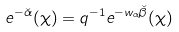Convert formula to latex. <formula><loc_0><loc_0><loc_500><loc_500>e ^ { - \check { \alpha } } ( \chi ) = q ^ { - 1 } e ^ { - w _ { \alpha } \check { \beta } } ( \chi )</formula> 